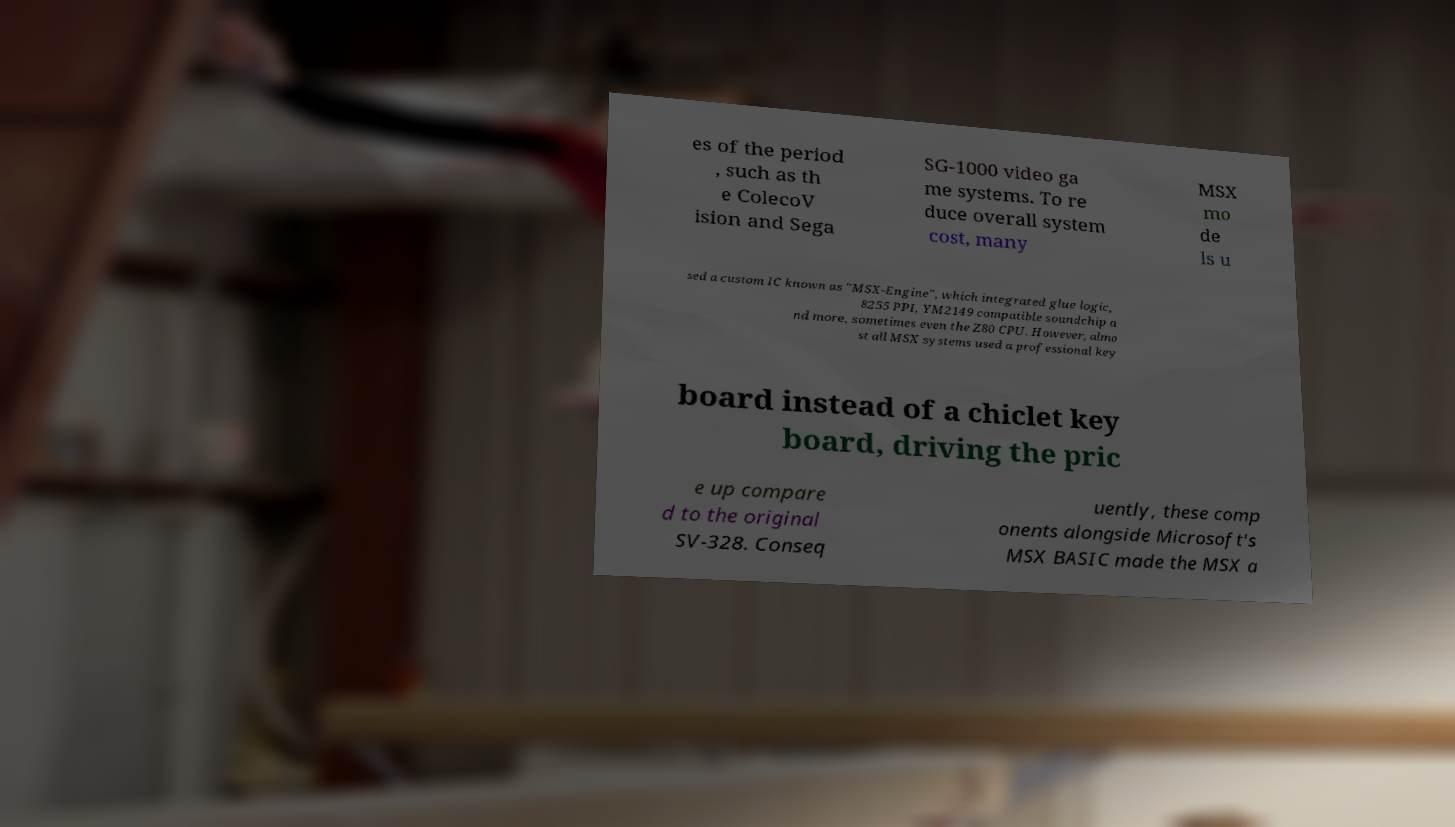Please read and relay the text visible in this image. What does it say? es of the period , such as th e ColecoV ision and Sega SG-1000 video ga me systems. To re duce overall system cost, many MSX mo de ls u sed a custom IC known as "MSX-Engine", which integrated glue logic, 8255 PPI, YM2149 compatible soundchip a nd more, sometimes even the Z80 CPU. However, almo st all MSX systems used a professional key board instead of a chiclet key board, driving the pric e up compare d to the original SV-328. Conseq uently, these comp onents alongside Microsoft's MSX BASIC made the MSX a 